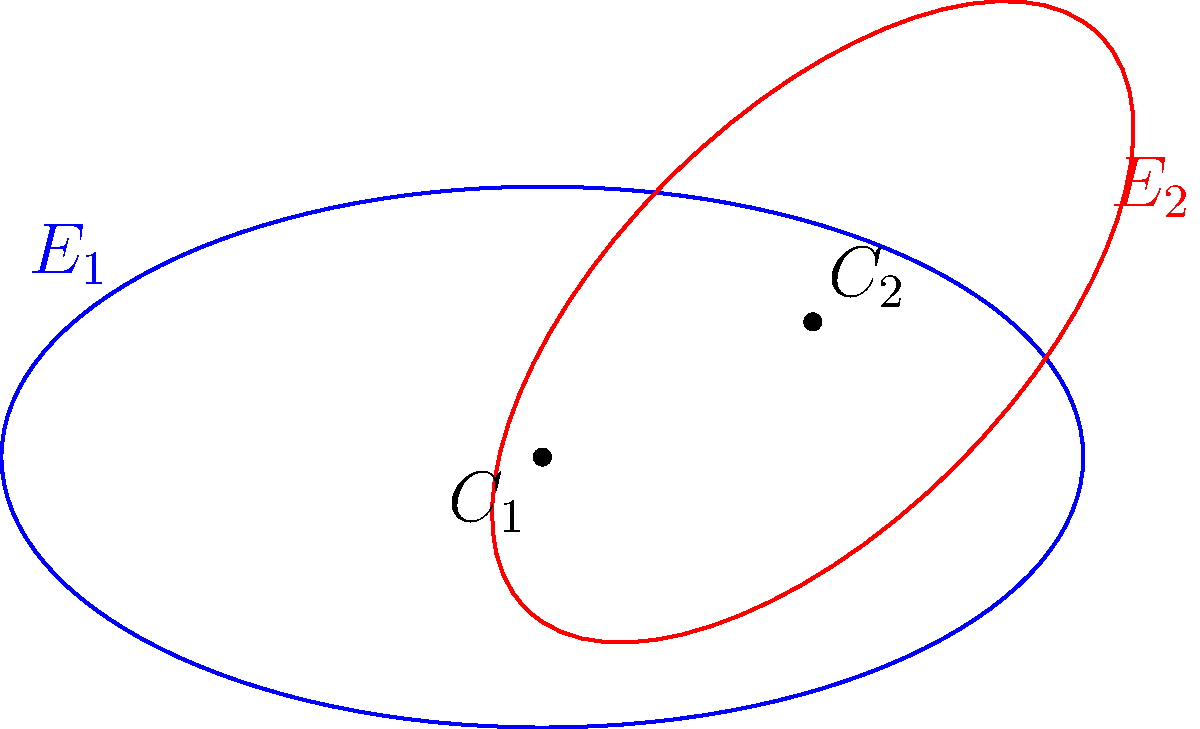Consider two ellipses $E_1$ and $E_2$ in the xy-plane, as shown in the figure. $E_1$ is centered at the origin with semi-major axis $a_1 = 4$ and semi-minor axis $b_1 = 2$, rotated counterclockwise by an angle $\theta_1 = 0$. $E_2$ is centered at (2,1) with semi-major axis $a_2 = 3$ and semi-minor axis $b_2 = 1.5$, rotated counterclockwise by an angle $\theta_2 = \frac{\pi}{4}$. Determine the system of equations that represents the points of intersection between these two ellipses. To find the system of equations representing the points of intersection, we need to:

1) Write the standard equations for both ellipses in their local coordinate systems.
2) Apply the necessary transformations (rotation and translation) to express both ellipses in the global coordinate system.
3) Set these equations equal to each other to find the points of intersection.

Step 1: Standard equations in local coordinate systems

For $E_1$: $\frac{x'^2}{16} + \frac{y'^2}{4} = 1$
For $E_2$: $\frac{x''^2}{9} + \frac{y''^2}{2.25} = 1$

Step 2: Apply transformations

For $E_1$ (no rotation, centered at origin):
$\frac{x^2}{16} + \frac{y^2}{4} = 1$

For $E_2$ (rotation by $\frac{\pi}{4}$, translation to (2,1)):
Let $(x', y')$ be the coordinates after rotation but before translation:
$x' = (x-2)\cos(\frac{\pi}{4}) + (y-1)\sin(\frac{\pi}{4})$
$y' = -(x-2)\sin(\frac{\pi}{4}) + (y-1)\cos(\frac{\pi}{4})$

Substituting into the equation of $E_2$:
$\frac{((x-2)\cos(\frac{\pi}{4}) + (y-1)\sin(\frac{\pi}{4}))^2}{9} + \frac{(-(x-2)\sin(\frac{\pi}{4}) + (y-1)\cos(\frac{\pi}{4}))^2}{2.25} = 1$

Step 3: Set equations equal

The system of equations representing the points of intersection is:

$$\begin{cases}
\frac{x^2}{16} + \frac{y^2}{4} = 1 \\
\frac{((x-2)\cos(\frac{\pi}{4}) + (y-1)\sin(\frac{\pi}{4}))^2}{9} + \frac{(-(x-2)\sin(\frac{\pi}{4}) + (y-1)\cos(\frac{\pi}{4}))^2}{2.25} = 1
\end{cases}$$

This system of equations, when solved, will give the coordinates of the intersection points between the two ellipses.
Answer: $$\begin{cases}
\frac{x^2}{16} + \frac{y^2}{4} = 1 \\
\frac{((x-2)\cos(\frac{\pi}{4}) + (y-1)\sin(\frac{\pi}{4}))^2}{9} + \frac{(-(x-2)\sin(\frac{\pi}{4}) + (y-1)\cos(\frac{\pi}{4}))^2}{2.25} = 1
\end{cases}$$ 